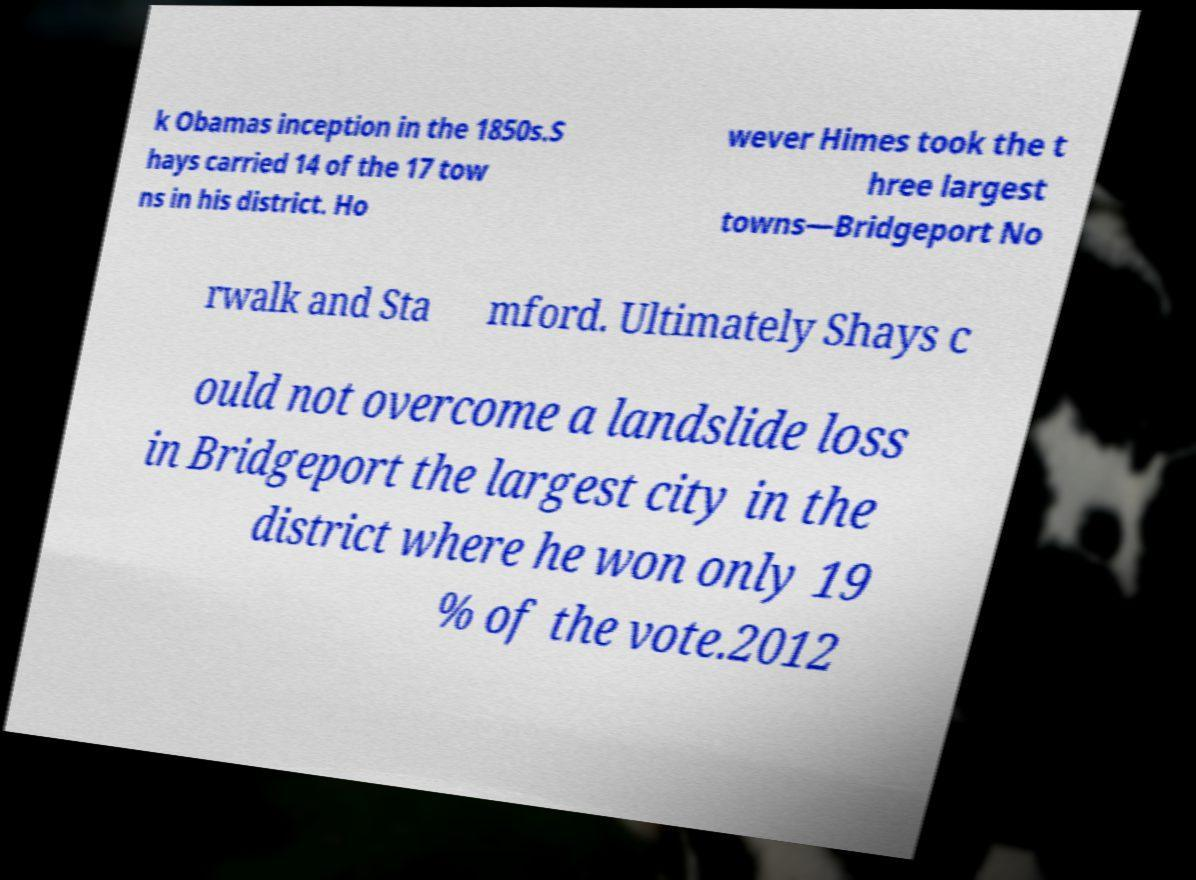Please read and relay the text visible in this image. What does it say? k Obamas inception in the 1850s.S hays carried 14 of the 17 tow ns in his district. Ho wever Himes took the t hree largest towns—Bridgeport No rwalk and Sta mford. Ultimately Shays c ould not overcome a landslide loss in Bridgeport the largest city in the district where he won only 19 % of the vote.2012 